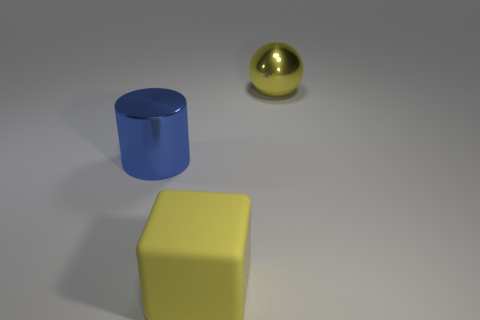There is a matte cube that is the same size as the yellow shiny sphere; what is its color?
Offer a very short reply. Yellow. There is a big object that is the same color as the big ball; what is its shape?
Your answer should be very brief. Cube. Is the number of yellow shiny objects to the left of the big blue cylinder the same as the number of blue shiny things that are left of the yellow metal ball?
Make the answer very short. No. There is a cylinder that is made of the same material as the yellow sphere; what is its size?
Your response must be concise. Large. There is a thing that is both on the right side of the blue shiny cylinder and left of the sphere; how big is it?
Ensure brevity in your answer.  Large. Is the size of the metallic object to the left of the shiny sphere the same as the yellow metal sphere?
Your response must be concise. Yes. What is the color of the big object that is in front of the large yellow metal thing and right of the cylinder?
Offer a very short reply. Yellow. There is a thing on the left side of the cube; how many large yellow shiny spheres are to the right of it?
Keep it short and to the point. 1. Is the shape of the large blue thing the same as the yellow rubber object?
Your answer should be compact. No. Is there any other thing of the same color as the shiny ball?
Offer a terse response. Yes. 